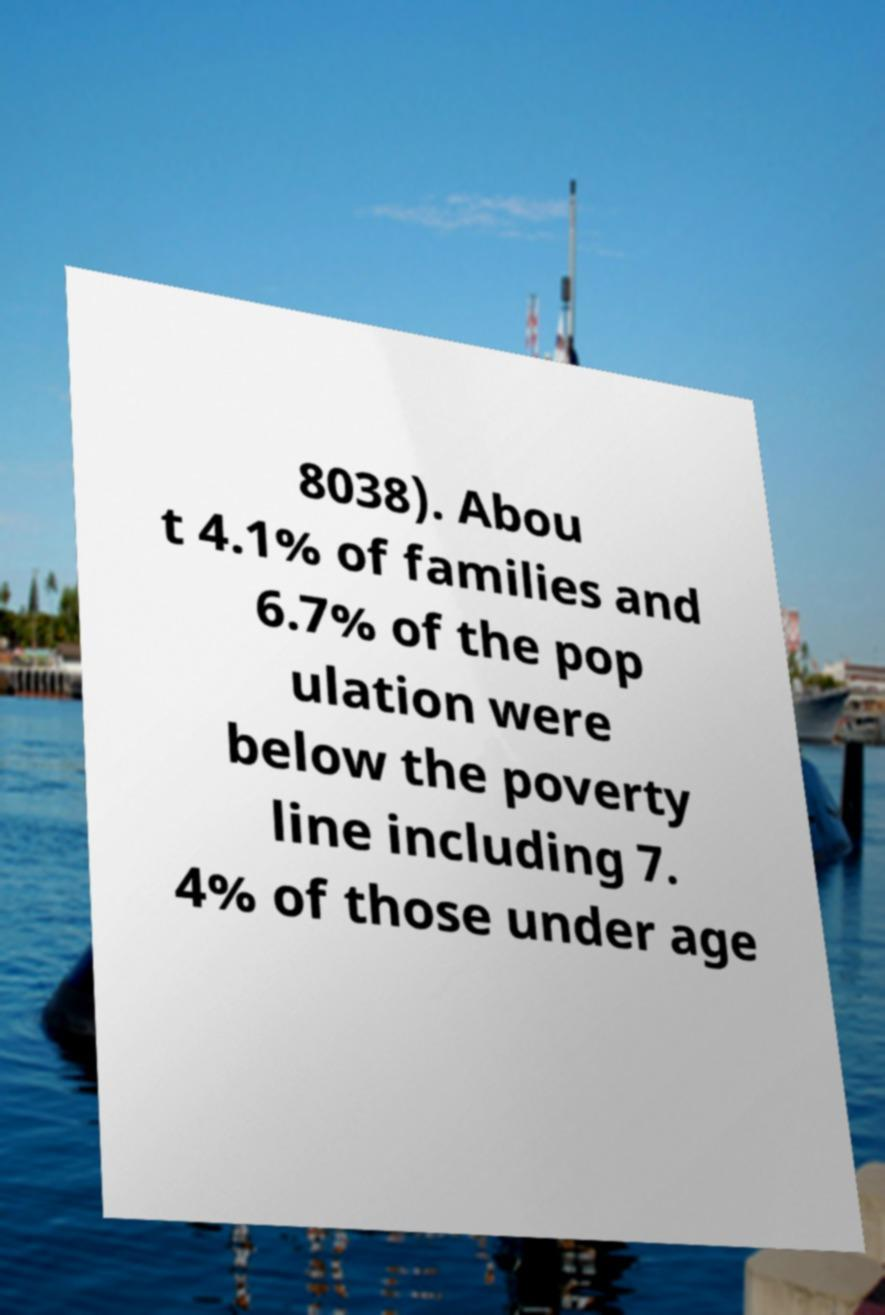Can you read and provide the text displayed in the image?This photo seems to have some interesting text. Can you extract and type it out for me? 8038). Abou t 4.1% of families and 6.7% of the pop ulation were below the poverty line including 7. 4% of those under age 